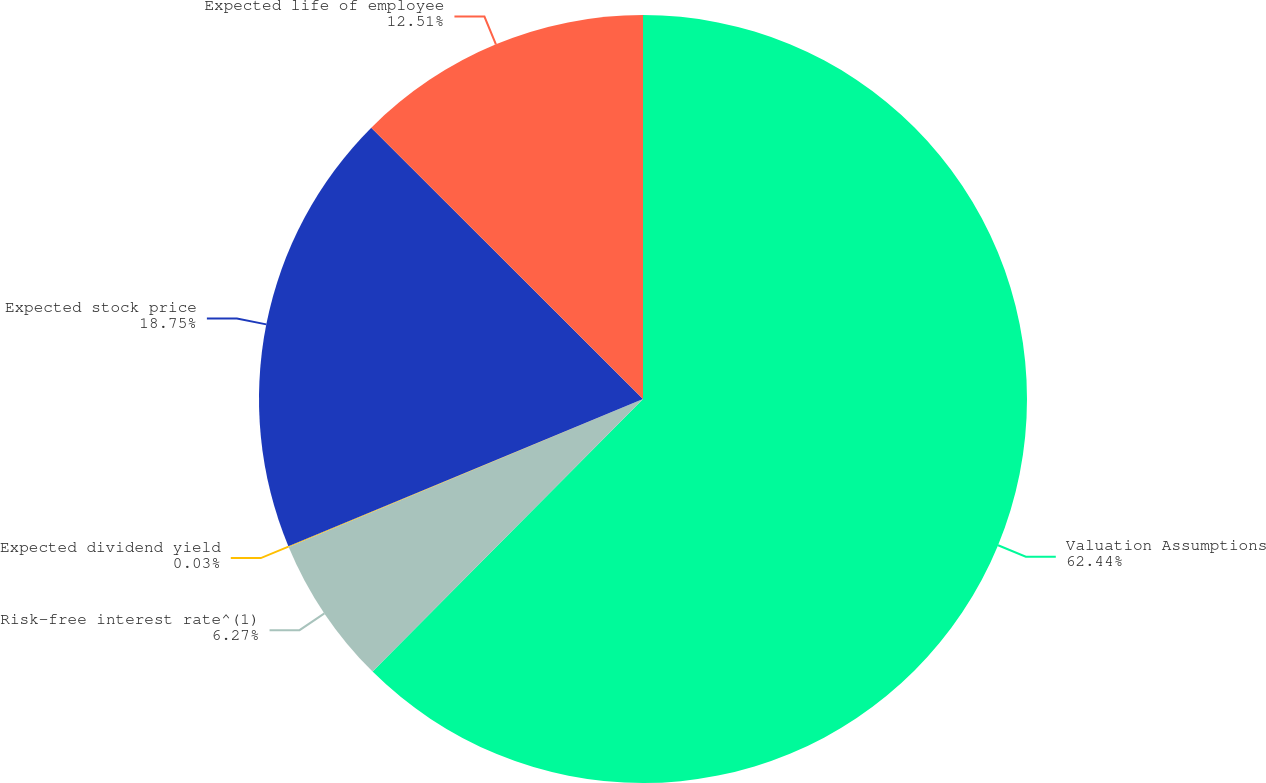Convert chart to OTSL. <chart><loc_0><loc_0><loc_500><loc_500><pie_chart><fcel>Valuation Assumptions<fcel>Risk-free interest rate^(1)<fcel>Expected dividend yield<fcel>Expected stock price<fcel>Expected life of employee<nl><fcel>62.43%<fcel>6.27%<fcel>0.03%<fcel>18.75%<fcel>12.51%<nl></chart> 